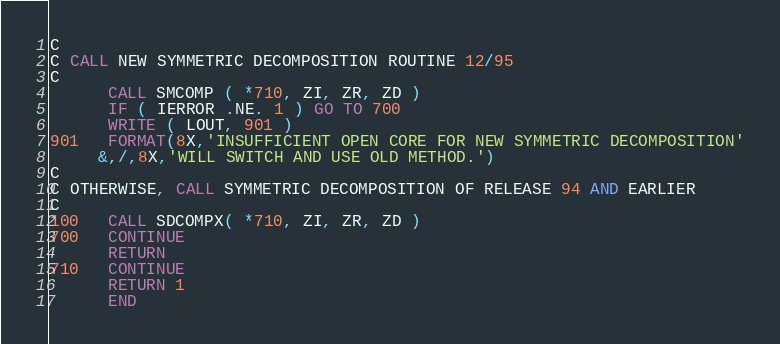<code> <loc_0><loc_0><loc_500><loc_500><_FORTRAN_>C
C CALL NEW SYMMETRIC DECOMPOSITION ROUTINE 12/95
C      
      CALL SMCOMP ( *710, ZI, ZR, ZD )
      IF ( IERROR .NE. 1 ) GO TO 700
      WRITE ( LOUT, 901 )
901   FORMAT(8X,'INSUFFICIENT OPEN CORE FOR NEW SYMMETRIC DECOMPOSITION'
     &,/,8X,'WILL SWITCH AND USE OLD METHOD.')
C
C OTHERWISE, CALL SYMMETRIC DECOMPOSITION OF RELEASE 94 AND EARLIER
C
100   CALL SDCOMPX( *710, ZI, ZR, ZD )
700   CONTINUE
      RETURN
710   CONTINUE
      RETURN 1
      END
</code> 